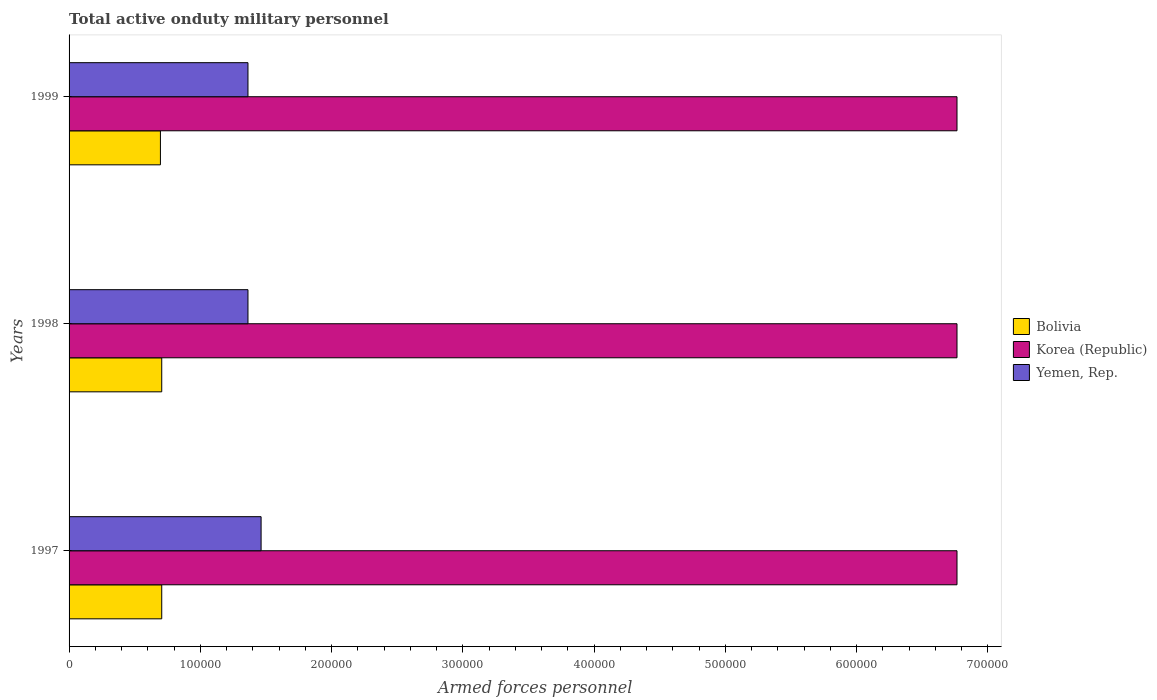How many different coloured bars are there?
Keep it short and to the point. 3. How many bars are there on the 1st tick from the top?
Provide a succinct answer. 3. What is the label of the 1st group of bars from the top?
Give a very brief answer. 1999. In how many cases, is the number of bars for a given year not equal to the number of legend labels?
Offer a very short reply. 0. What is the number of armed forces personnel in Yemen, Rep. in 1998?
Your response must be concise. 1.36e+05. Across all years, what is the maximum number of armed forces personnel in Yemen, Rep.?
Make the answer very short. 1.46e+05. Across all years, what is the minimum number of armed forces personnel in Korea (Republic)?
Give a very brief answer. 6.76e+05. What is the total number of armed forces personnel in Yemen, Rep. in the graph?
Your response must be concise. 4.19e+05. What is the difference between the number of armed forces personnel in Bolivia in 1998 and that in 1999?
Your response must be concise. 1000. What is the difference between the number of armed forces personnel in Korea (Republic) in 1997 and the number of armed forces personnel in Yemen, Rep. in 1999?
Ensure brevity in your answer.  5.40e+05. What is the average number of armed forces personnel in Yemen, Rep. per year?
Make the answer very short. 1.40e+05. In the year 1999, what is the difference between the number of armed forces personnel in Korea (Republic) and number of armed forces personnel in Bolivia?
Give a very brief answer. 6.07e+05. What is the ratio of the number of armed forces personnel in Yemen, Rep. in 1997 to that in 1999?
Keep it short and to the point. 1.07. Is the number of armed forces personnel in Bolivia in 1998 less than that in 1999?
Ensure brevity in your answer.  No. Is the difference between the number of armed forces personnel in Korea (Republic) in 1998 and 1999 greater than the difference between the number of armed forces personnel in Bolivia in 1998 and 1999?
Your answer should be compact. No. What is the difference between the highest and the second highest number of armed forces personnel in Bolivia?
Ensure brevity in your answer.  0. In how many years, is the number of armed forces personnel in Bolivia greater than the average number of armed forces personnel in Bolivia taken over all years?
Keep it short and to the point. 2. What does the 2nd bar from the top in 1998 represents?
Keep it short and to the point. Korea (Republic). Is it the case that in every year, the sum of the number of armed forces personnel in Bolivia and number of armed forces personnel in Korea (Republic) is greater than the number of armed forces personnel in Yemen, Rep.?
Your response must be concise. Yes. Are all the bars in the graph horizontal?
Provide a succinct answer. Yes. How many years are there in the graph?
Your answer should be very brief. 3. What is the difference between two consecutive major ticks on the X-axis?
Your answer should be very brief. 1.00e+05. Are the values on the major ticks of X-axis written in scientific E-notation?
Make the answer very short. No. Does the graph contain any zero values?
Offer a very short reply. No. Where does the legend appear in the graph?
Keep it short and to the point. Center right. How many legend labels are there?
Offer a very short reply. 3. How are the legend labels stacked?
Your response must be concise. Vertical. What is the title of the graph?
Give a very brief answer. Total active onduty military personnel. What is the label or title of the X-axis?
Provide a short and direct response. Armed forces personnel. What is the Armed forces personnel in Bolivia in 1997?
Your response must be concise. 7.06e+04. What is the Armed forces personnel in Korea (Republic) in 1997?
Provide a short and direct response. 6.76e+05. What is the Armed forces personnel in Yemen, Rep. in 1997?
Ensure brevity in your answer.  1.46e+05. What is the Armed forces personnel of Bolivia in 1998?
Offer a very short reply. 7.06e+04. What is the Armed forces personnel of Korea (Republic) in 1998?
Ensure brevity in your answer.  6.76e+05. What is the Armed forces personnel in Yemen, Rep. in 1998?
Give a very brief answer. 1.36e+05. What is the Armed forces personnel in Bolivia in 1999?
Provide a short and direct response. 6.96e+04. What is the Armed forces personnel in Korea (Republic) in 1999?
Make the answer very short. 6.76e+05. What is the Armed forces personnel in Yemen, Rep. in 1999?
Offer a very short reply. 1.36e+05. Across all years, what is the maximum Armed forces personnel in Bolivia?
Provide a succinct answer. 7.06e+04. Across all years, what is the maximum Armed forces personnel of Korea (Republic)?
Provide a short and direct response. 6.76e+05. Across all years, what is the maximum Armed forces personnel in Yemen, Rep.?
Your response must be concise. 1.46e+05. Across all years, what is the minimum Armed forces personnel of Bolivia?
Provide a short and direct response. 6.96e+04. Across all years, what is the minimum Armed forces personnel in Korea (Republic)?
Your response must be concise. 6.76e+05. Across all years, what is the minimum Armed forces personnel in Yemen, Rep.?
Offer a terse response. 1.36e+05. What is the total Armed forces personnel of Bolivia in the graph?
Provide a succinct answer. 2.11e+05. What is the total Armed forces personnel in Korea (Republic) in the graph?
Keep it short and to the point. 2.03e+06. What is the total Armed forces personnel in Yemen, Rep. in the graph?
Make the answer very short. 4.19e+05. What is the difference between the Armed forces personnel in Korea (Republic) in 1997 and that in 1998?
Keep it short and to the point. 0. What is the difference between the Armed forces personnel of Yemen, Rep. in 1997 and that in 1998?
Ensure brevity in your answer.  10000. What is the difference between the Armed forces personnel of Korea (Republic) in 1997 and that in 1999?
Provide a short and direct response. 0. What is the difference between the Armed forces personnel in Yemen, Rep. in 1997 and that in 1999?
Keep it short and to the point. 10000. What is the difference between the Armed forces personnel of Bolivia in 1998 and that in 1999?
Give a very brief answer. 1000. What is the difference between the Armed forces personnel in Korea (Republic) in 1998 and that in 1999?
Provide a succinct answer. 0. What is the difference between the Armed forces personnel of Bolivia in 1997 and the Armed forces personnel of Korea (Republic) in 1998?
Your response must be concise. -6.06e+05. What is the difference between the Armed forces personnel of Bolivia in 1997 and the Armed forces personnel of Yemen, Rep. in 1998?
Provide a short and direct response. -6.57e+04. What is the difference between the Armed forces personnel in Korea (Republic) in 1997 and the Armed forces personnel in Yemen, Rep. in 1998?
Give a very brief answer. 5.40e+05. What is the difference between the Armed forces personnel of Bolivia in 1997 and the Armed forces personnel of Korea (Republic) in 1999?
Keep it short and to the point. -6.06e+05. What is the difference between the Armed forces personnel of Bolivia in 1997 and the Armed forces personnel of Yemen, Rep. in 1999?
Your answer should be very brief. -6.57e+04. What is the difference between the Armed forces personnel in Korea (Republic) in 1997 and the Armed forces personnel in Yemen, Rep. in 1999?
Your answer should be compact. 5.40e+05. What is the difference between the Armed forces personnel of Bolivia in 1998 and the Armed forces personnel of Korea (Republic) in 1999?
Give a very brief answer. -6.06e+05. What is the difference between the Armed forces personnel of Bolivia in 1998 and the Armed forces personnel of Yemen, Rep. in 1999?
Your response must be concise. -6.57e+04. What is the difference between the Armed forces personnel of Korea (Republic) in 1998 and the Armed forces personnel of Yemen, Rep. in 1999?
Keep it short and to the point. 5.40e+05. What is the average Armed forces personnel in Bolivia per year?
Keep it short and to the point. 7.03e+04. What is the average Armed forces personnel of Korea (Republic) per year?
Your answer should be compact. 6.76e+05. What is the average Armed forces personnel of Yemen, Rep. per year?
Offer a terse response. 1.40e+05. In the year 1997, what is the difference between the Armed forces personnel in Bolivia and Armed forces personnel in Korea (Republic)?
Give a very brief answer. -6.06e+05. In the year 1997, what is the difference between the Armed forces personnel of Bolivia and Armed forces personnel of Yemen, Rep.?
Ensure brevity in your answer.  -7.57e+04. In the year 1997, what is the difference between the Armed forces personnel of Korea (Republic) and Armed forces personnel of Yemen, Rep.?
Provide a short and direct response. 5.30e+05. In the year 1998, what is the difference between the Armed forces personnel of Bolivia and Armed forces personnel of Korea (Republic)?
Your answer should be compact. -6.06e+05. In the year 1998, what is the difference between the Armed forces personnel of Bolivia and Armed forces personnel of Yemen, Rep.?
Your answer should be very brief. -6.57e+04. In the year 1998, what is the difference between the Armed forces personnel in Korea (Republic) and Armed forces personnel in Yemen, Rep.?
Give a very brief answer. 5.40e+05. In the year 1999, what is the difference between the Armed forces personnel in Bolivia and Armed forces personnel in Korea (Republic)?
Keep it short and to the point. -6.07e+05. In the year 1999, what is the difference between the Armed forces personnel in Bolivia and Armed forces personnel in Yemen, Rep.?
Give a very brief answer. -6.67e+04. In the year 1999, what is the difference between the Armed forces personnel in Korea (Republic) and Armed forces personnel in Yemen, Rep.?
Keep it short and to the point. 5.40e+05. What is the ratio of the Armed forces personnel of Korea (Republic) in 1997 to that in 1998?
Provide a short and direct response. 1. What is the ratio of the Armed forces personnel in Yemen, Rep. in 1997 to that in 1998?
Your response must be concise. 1.07. What is the ratio of the Armed forces personnel of Bolivia in 1997 to that in 1999?
Provide a short and direct response. 1.01. What is the ratio of the Armed forces personnel of Korea (Republic) in 1997 to that in 1999?
Your response must be concise. 1. What is the ratio of the Armed forces personnel of Yemen, Rep. in 1997 to that in 1999?
Ensure brevity in your answer.  1.07. What is the ratio of the Armed forces personnel in Bolivia in 1998 to that in 1999?
Your response must be concise. 1.01. What is the ratio of the Armed forces personnel in Korea (Republic) in 1998 to that in 1999?
Offer a terse response. 1. What is the difference between the highest and the second highest Armed forces personnel in Bolivia?
Ensure brevity in your answer.  0. What is the difference between the highest and the second highest Armed forces personnel in Korea (Republic)?
Make the answer very short. 0. What is the difference between the highest and the lowest Armed forces personnel in Bolivia?
Provide a succinct answer. 1000. What is the difference between the highest and the lowest Armed forces personnel in Korea (Republic)?
Provide a short and direct response. 0. What is the difference between the highest and the lowest Armed forces personnel in Yemen, Rep.?
Your answer should be very brief. 10000. 